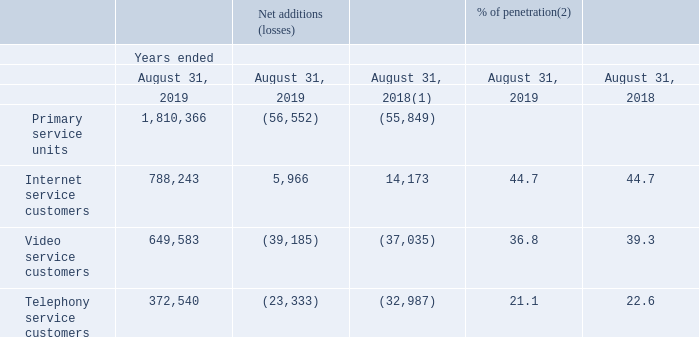CUSTOMER STATISTICS
(1) Excludes adjustments related to the migration to the new customer management system implemented during the third quarter of fiscal 2018.
(2) As a percentage of homes passed.
During the third quarter of fiscal 2018, the Canadian broadband services segment implemented a new customer management system, replacing 22 legacy systems. While the customer management system was still in the stabilization phase, contact center congestion resulted in lower services activations during most of the fourth quarter of fiscal 2018 and the first quarter of 2019. Contact center and marketing operations had returned to normal at the end of the first quarter of 2019.
Variations of each services are also explained as follows:
INTERNET Fiscal 2019 Internet service customers net additions stood at 5,966 compared to 14,173 for the prior year mainly due to: • the ongoing interest in high speed offerings; • the sustained interest in bundle offers; and • the increased demand from Internet resellers; partly offset by • competitive offers in the industry; and • contact center congestion during the stabilization period of the new customer management system.
VIDEO Fiscal 2019 video service customers net losses stood at 39,185 compared to 37,035 for the prior year as a result of: • highly competitive offers in the industry; • a changing video consumption environment; and • contact center congestion during the stabilization period of the new customer management system; partly offset by • customers' ongoing interest in digital advanced video services; and • customers' interest in video services bundled with fast Internet offerings.
TELEPHONY Fiscal 2019 telephony service customers net losses amounted to 23,333 compared to 32,987 for the prior year mainly due to: • technical issues with telephony activations following the implementation of the new customer management system which were resolved at the end of the first quarter; • increasing wireless penetration in North America and various unlimited offers launched by wireless operators causing some customers to cancel their landline telephony services for wireless telephony services only; partly offset by • growth in the business sector; and • more telephony bundles due to additional promotional activity in the second half of fiscal 2019.
DISTRIBUTION OF CUSTOMERS At August 31, 2019, 69% of the Canadian broadband services segment's customers enjoyed "double play" or "triple play" bundled services.
How many legacy systems were replaced by implementing the new customer management system? 22. What were the net additions of the internet customers in 2019? 5,966. What was the net loss for video customers in 2019? 39,185. What was the increase / (decrease) in the net additions of Primary service units in 2019 from 2018? -56,552 - (-55,849)
Answer: -703. What was the average increase / (decrease) in the internet service customers between 2018 and 2019? (5,966 + 14,173) / 2
Answer: 10069.5. What was the average increase / (decrease) in video service customers between 2018 and 2019? -(39,185 + 37,035) / 2
Answer: -38110. 